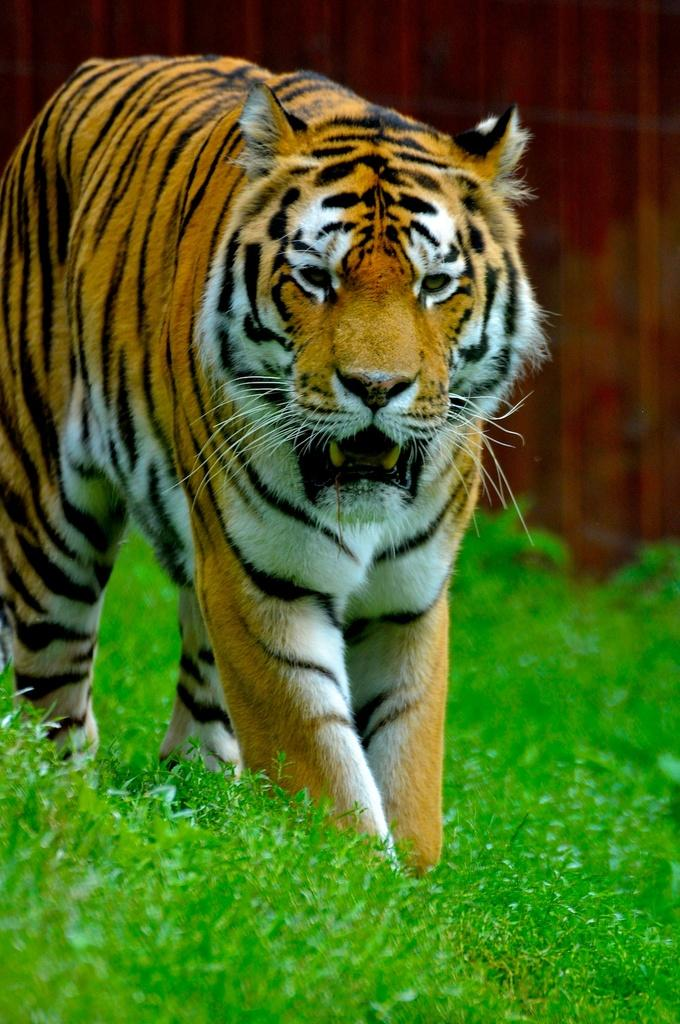What animal is in the center of the image? There is a tiger in the center of the image. What type of vegetation is at the bottom of the image? There is grass at the bottom of the image. What brand of toothpaste is the tiger using in the image? There is no toothpaste present in the image, and the tiger is not using any toothpaste. 